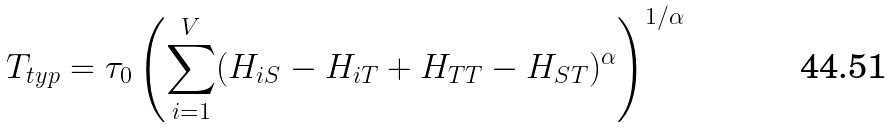<formula> <loc_0><loc_0><loc_500><loc_500>T _ { t y p } = \tau _ { 0 } \left ( \sum _ { i = 1 } ^ { V } ( H _ { i S } - H _ { i T } + H _ { T T } - H _ { S T } ) ^ { \alpha } \right ) ^ { 1 / \alpha }</formula> 